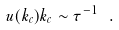<formula> <loc_0><loc_0><loc_500><loc_500>u ( k _ { c } ) k _ { c } \sim \tau ^ { - 1 } \ .</formula> 